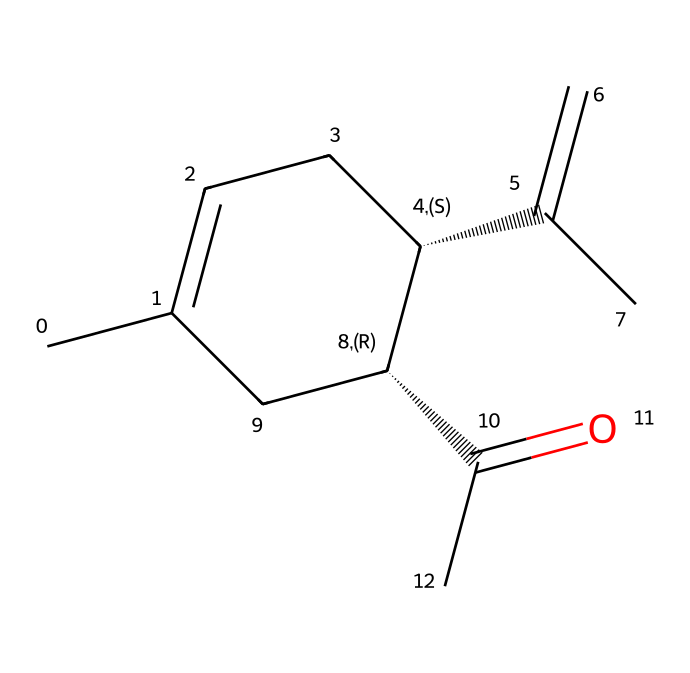What is the molecular formula of carvone? To determine the molecular formula, count the number of each type of atom in the SMILES representation. The structure consists of 10 carbon (C), 14 hydrogen (H), and 1 oxygen (O) atoms. Therefore, the molecular formula is C10H14O.
Answer: C10H14O How many chiral centers does carvone have? A chiral center is typically a carbon atom that is bonded to four different groups. In the SMILES representation, there are two "@H" symbols indicating the presence of two chiral centers in carvone.
Answer: 2 What is the role of carvone in caraway seeds? Carvone provides the distinct aroma characteristic of caraway seeds, contributing to their flavor profile. It is a flavor compound responsible for the seed's unique scent.
Answer: aroma Which type of stereoisomer does the presence of chiral centers in carvone create? The chiral centers in carvone lead to the formation of enantiomers, which are non-superimposable mirror images of each other.
Answer: enantiomers How many rings are present in the structure of carvone? By examining the SMILES representation, the presence of "C1" and the corresponding closing pattern indicates that there is one ring structure in carvone.
Answer: 1 What is the functional group present in carvone? The presence of "C(=O)" indicates that carvone contains a ketone functional group, characterized by a carbon atom double-bonded to an oxygen atom.
Answer: ketone 